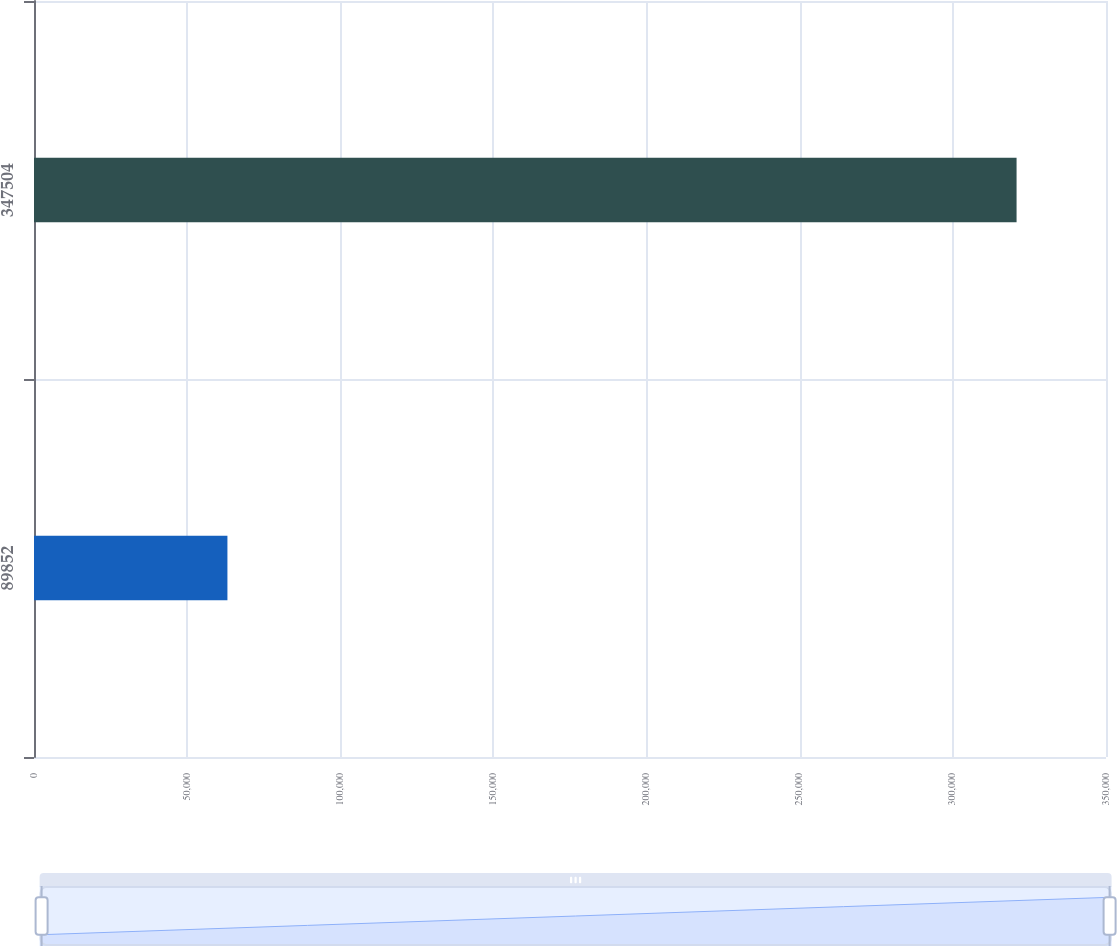Convert chart. <chart><loc_0><loc_0><loc_500><loc_500><bar_chart><fcel>89852<fcel>347504<nl><fcel>63151<fcel>320803<nl></chart> 